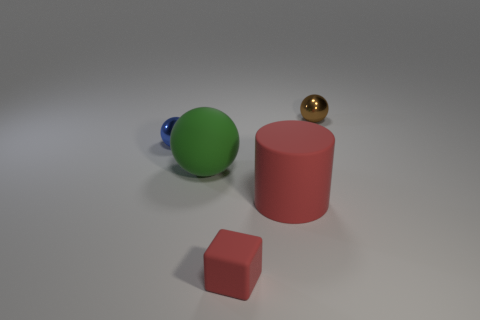Are there fewer big matte balls than small cyan metal balls? Based on the image, it appears that there is an equal number of big green matte balls and small golden metal balls, which is one each. So, the answer to whether there are fewer big matte balls than small cyan metal balls would be no since there are equal numbers of each, with one ball present for each described type. 